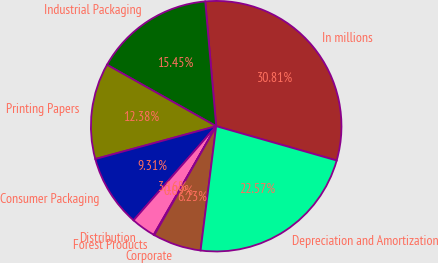Convert chart to OTSL. <chart><loc_0><loc_0><loc_500><loc_500><pie_chart><fcel>In millions<fcel>Industrial Packaging<fcel>Printing Papers<fcel>Consumer Packaging<fcel>Distribution<fcel>Forest Products<fcel>Corporate<fcel>Depreciation and Amortization<nl><fcel>30.81%<fcel>15.45%<fcel>12.38%<fcel>9.31%<fcel>3.16%<fcel>0.09%<fcel>6.23%<fcel>22.57%<nl></chart> 